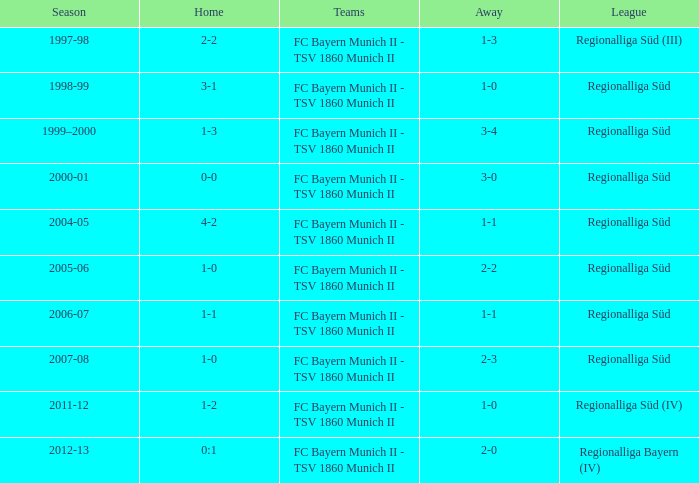Which season has the regionalliga süd (iii) league? 1997-98. 